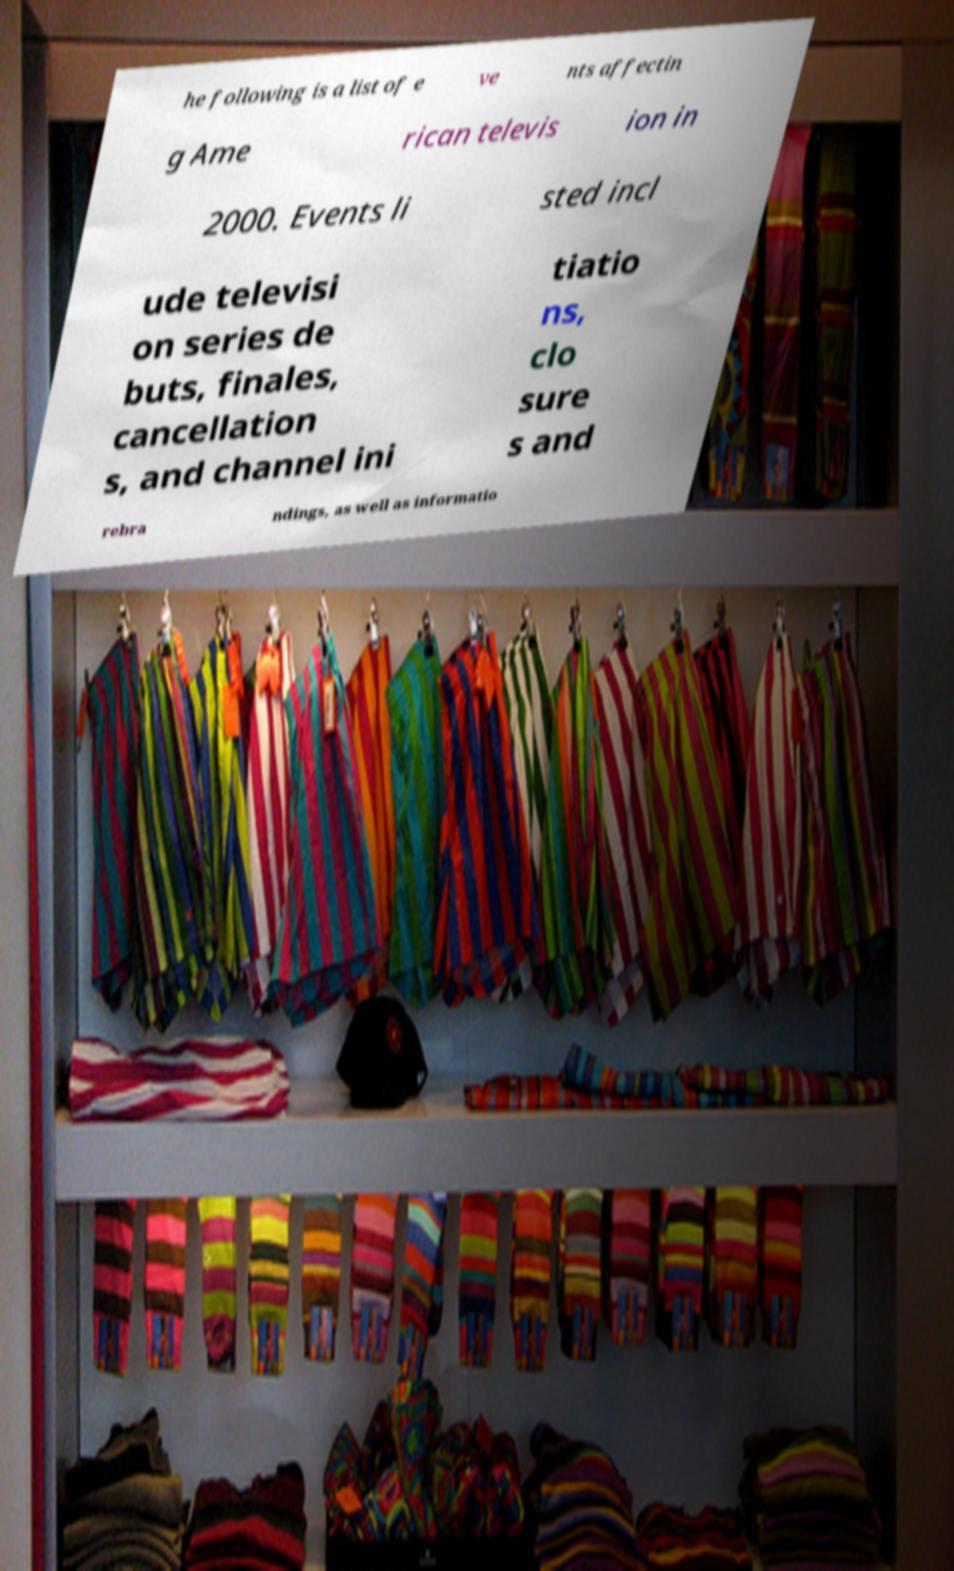Could you extract and type out the text from this image? he following is a list of e ve nts affectin g Ame rican televis ion in 2000. Events li sted incl ude televisi on series de buts, finales, cancellation s, and channel ini tiatio ns, clo sure s and rebra ndings, as well as informatio 